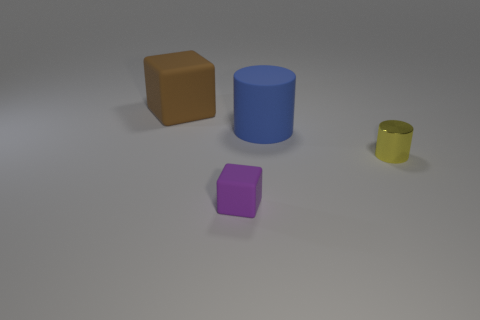Which object stands out the most to you? The blue cylinder stands out due to its vibrant color and being the tallest object, drawing the viewer's eye amidst the other, smaller objects. In terms of visual design, how do these objects interact with each other? Visually, the objects create a harmonious composition with contrasting shapes and colors. The different sizes and colors provide variety and depth, while the placement of the objects leads to a balanced and uncluttered scene. 